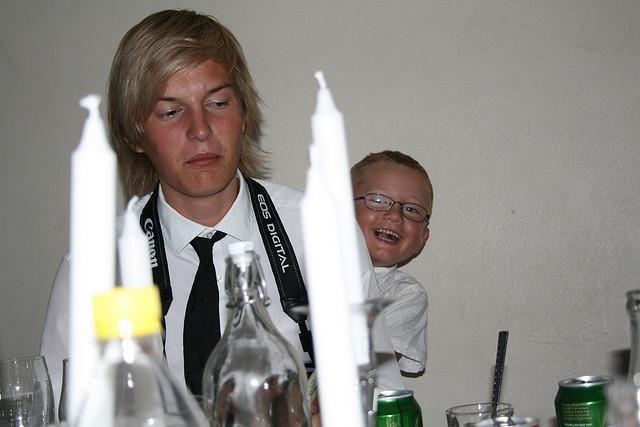How many bottles are visible?
Give a very brief answer. 2. How many people are there?
Give a very brief answer. 2. How many giraffes are in this picture?
Give a very brief answer. 0. 